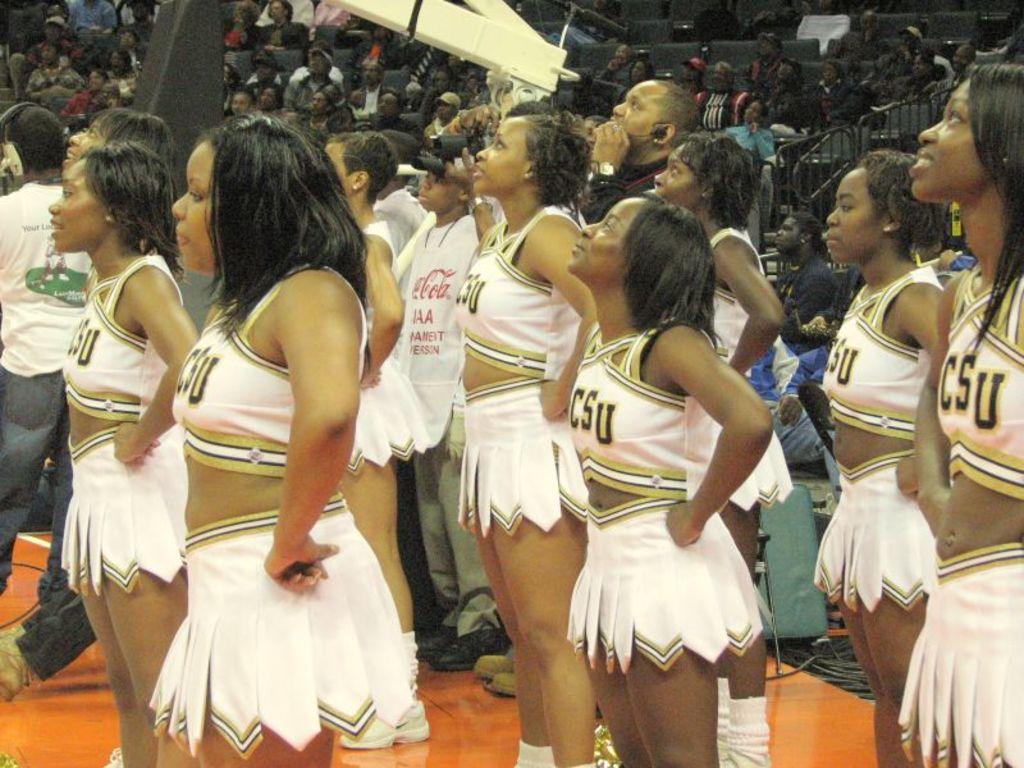What school do they cheer for?
Offer a very short reply. Csu. What two letter can be seen written on the white shirt?
Ensure brevity in your answer.  Csu. 